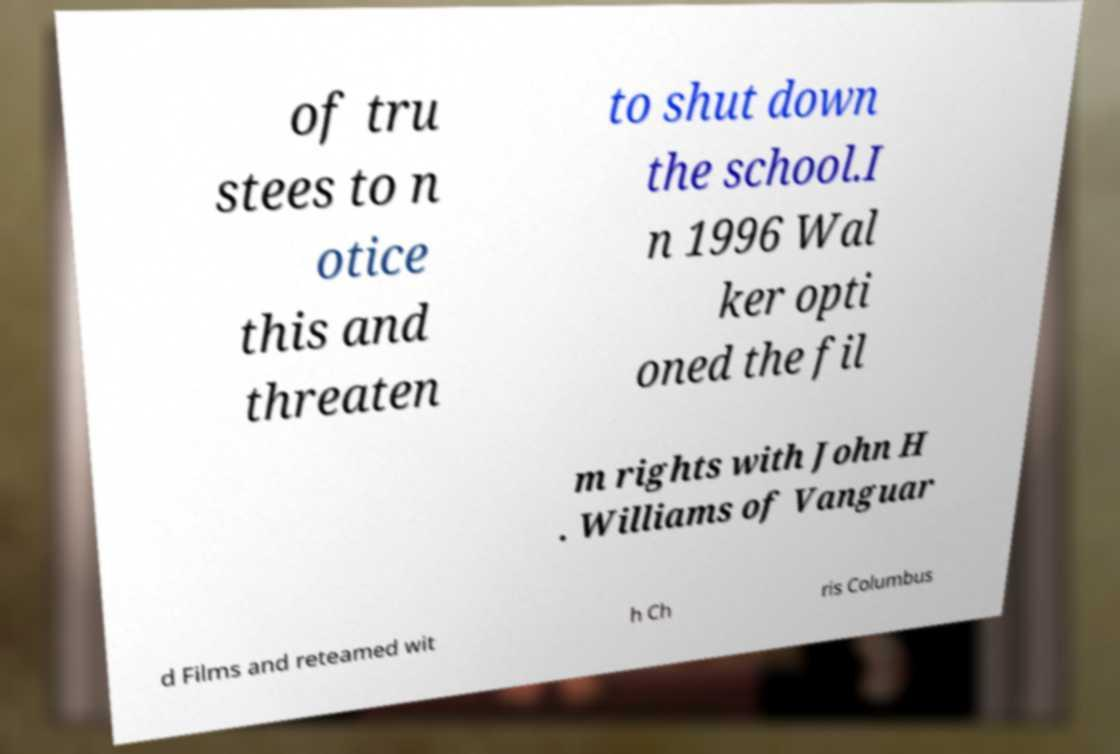I need the written content from this picture converted into text. Can you do that? of tru stees to n otice this and threaten to shut down the school.I n 1996 Wal ker opti oned the fil m rights with John H . Williams of Vanguar d Films and reteamed wit h Ch ris Columbus 